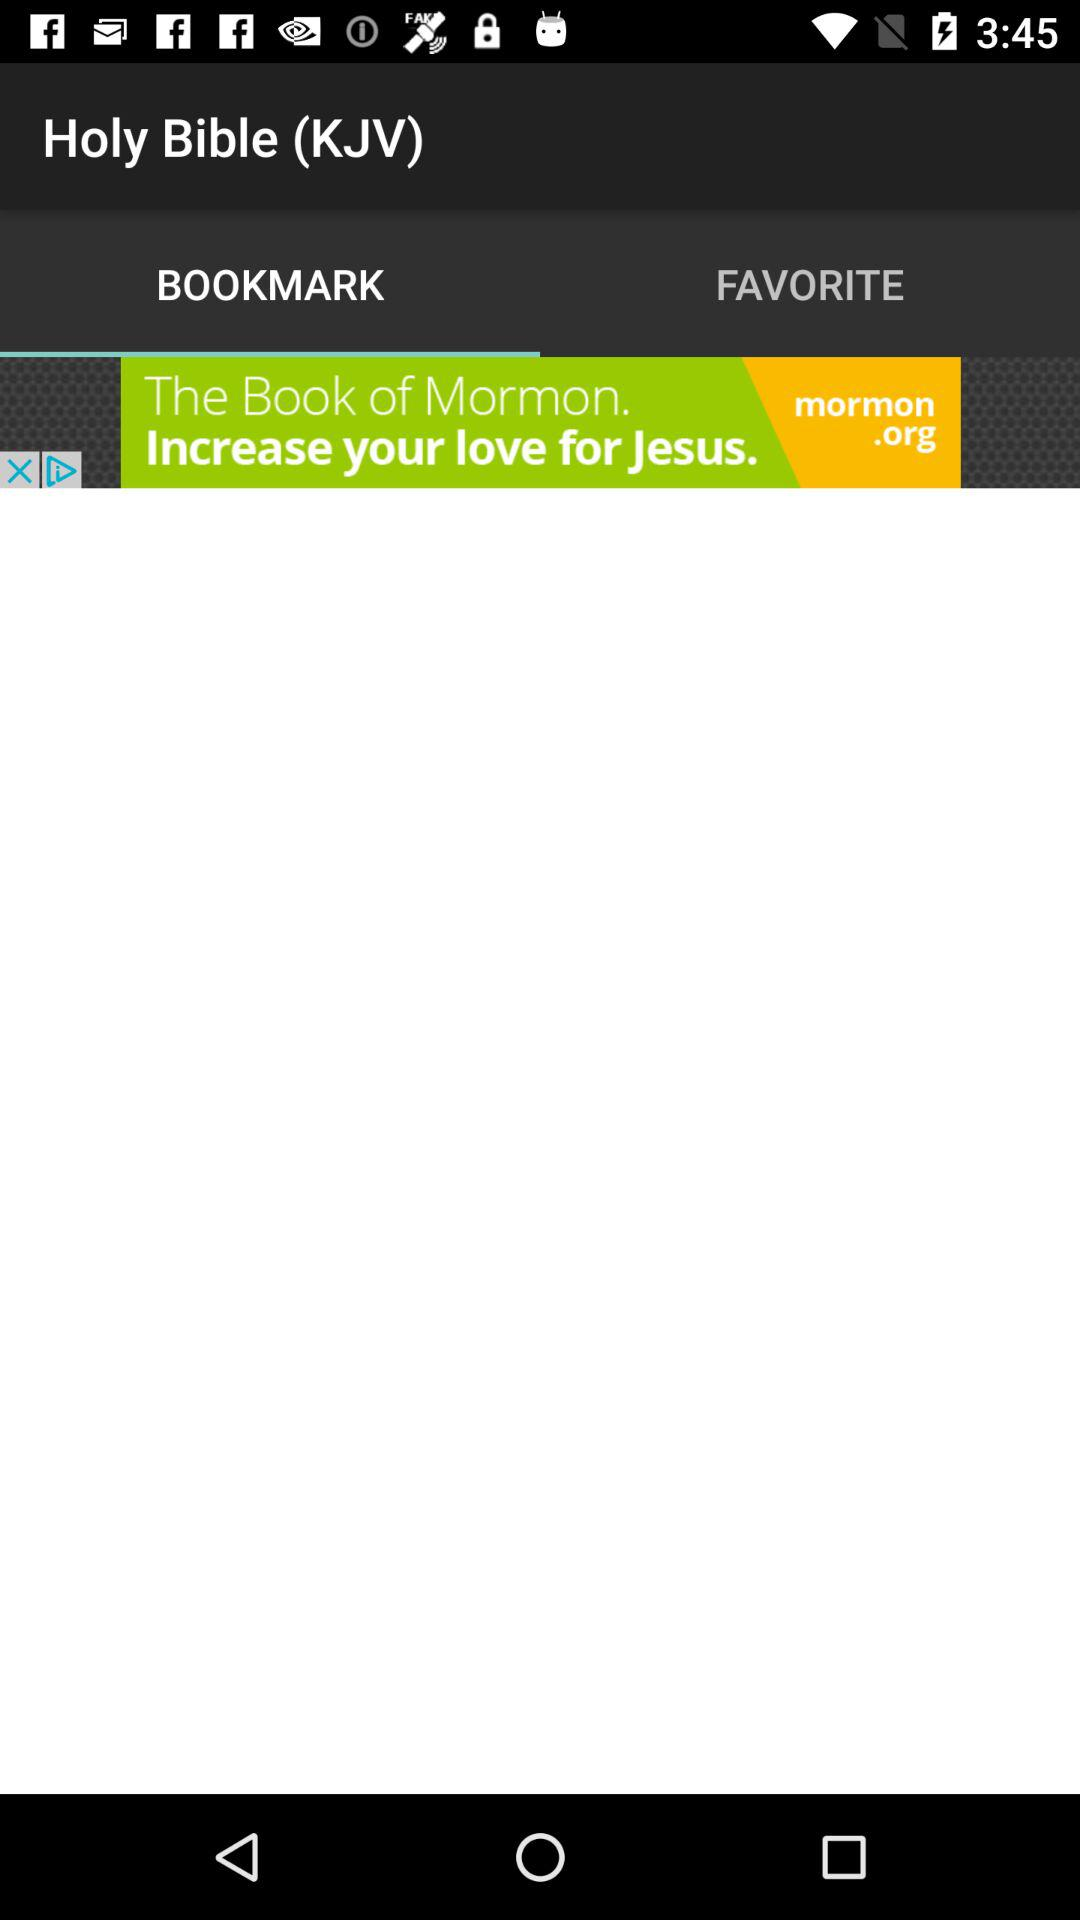What is the application name? The application name is "Holy Bible (KJV)". 